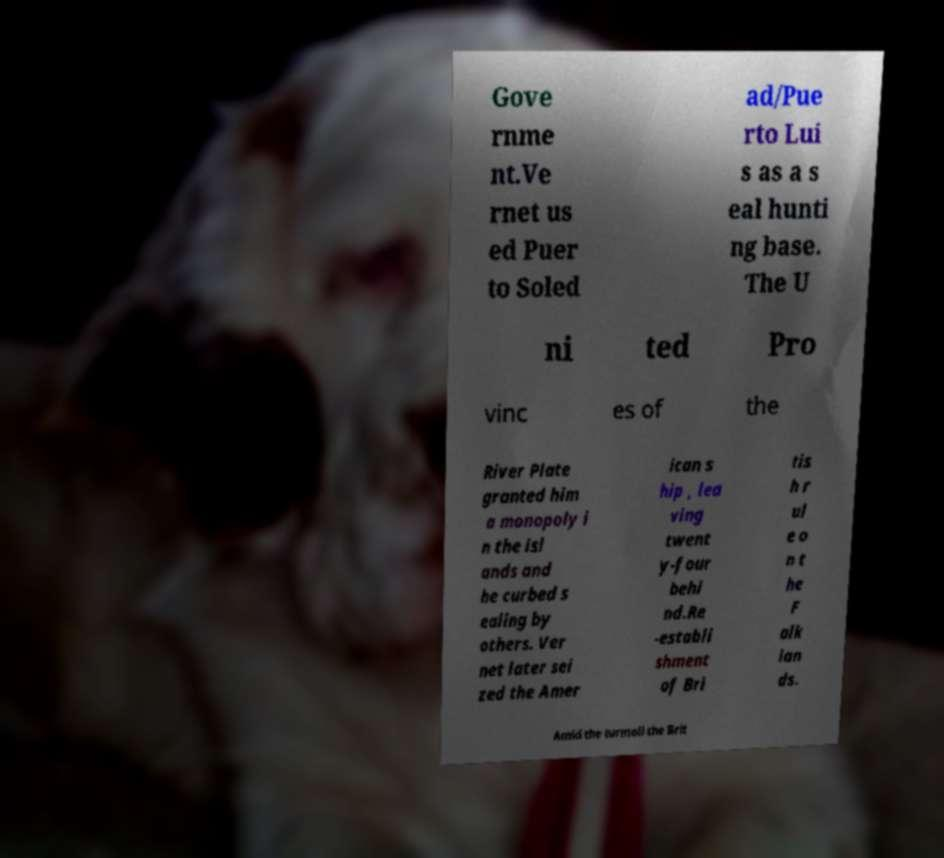For documentation purposes, I need the text within this image transcribed. Could you provide that? Gove rnme nt.Ve rnet us ed Puer to Soled ad/Pue rto Lui s as a s eal hunti ng base. The U ni ted Pro vinc es of the River Plate granted him a monopoly i n the isl ands and he curbed s ealing by others. Ver net later sei zed the Amer ican s hip , lea ving twent y-four behi nd.Re -establi shment of Bri tis h r ul e o n t he F alk lan ds. Amid the turmoil the Brit 